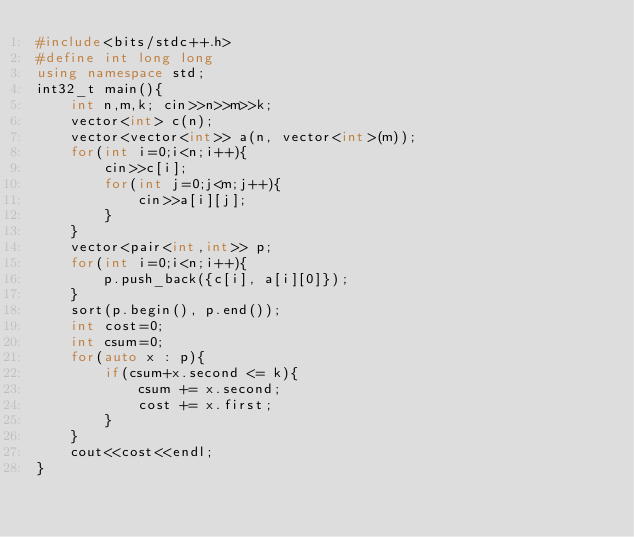<code> <loc_0><loc_0><loc_500><loc_500><_C++_>#include<bits/stdc++.h>
#define int long long
using namespace std;
int32_t main(){
    int n,m,k; cin>>n>>m>>k;
    vector<int> c(n);
    vector<vector<int>> a(n, vector<int>(m));
    for(int i=0;i<n;i++){
        cin>>c[i];
        for(int j=0;j<m;j++){
            cin>>a[i][j];
        }
    }
    vector<pair<int,int>> p;
    for(int i=0;i<n;i++){
        p.push_back({c[i], a[i][0]});
    }
    sort(p.begin(), p.end());
    int cost=0;
    int csum=0;
    for(auto x : p){
        if(csum+x.second <= k){
            csum += x.second;
            cost += x.first;
        }
    }
    cout<<cost<<endl;
}</code> 